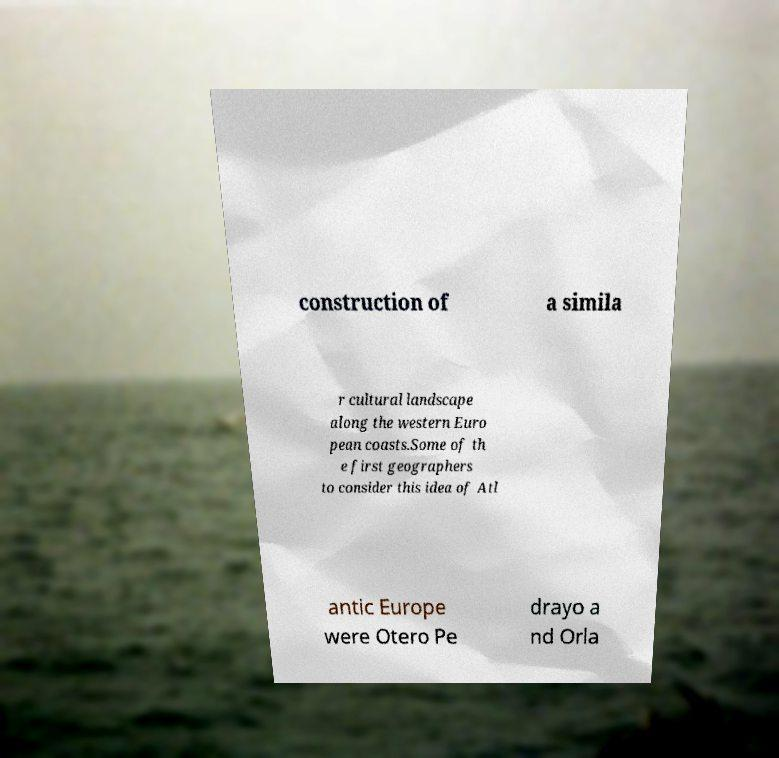Could you extract and type out the text from this image? construction of a simila r cultural landscape along the western Euro pean coasts.Some of th e first geographers to consider this idea of Atl antic Europe were Otero Pe drayo a nd Orla 